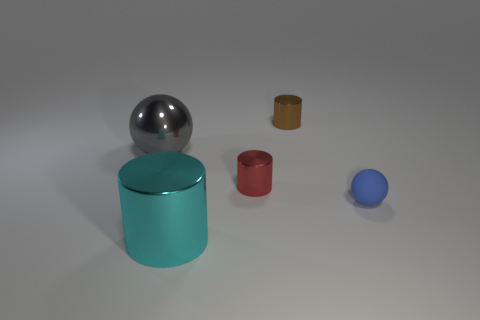Add 4 red objects. How many objects exist? 9 Subtract 0 green blocks. How many objects are left? 5 Subtract all balls. How many objects are left? 3 Subtract all blue shiny cylinders. Subtract all tiny rubber objects. How many objects are left? 4 Add 5 big cyan cylinders. How many big cyan cylinders are left? 6 Add 4 big gray metal things. How many big gray metal things exist? 5 